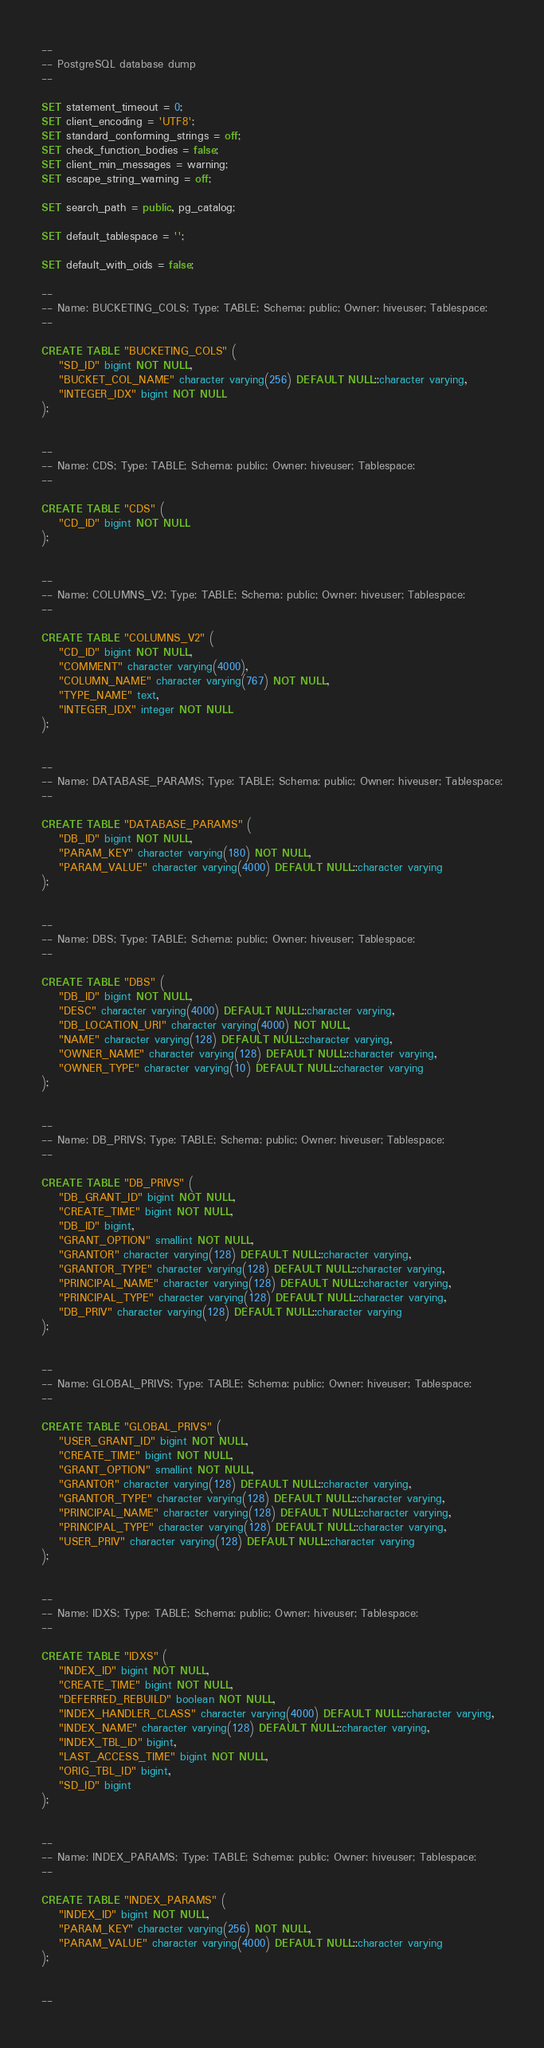Convert code to text. <code><loc_0><loc_0><loc_500><loc_500><_SQL_>--
-- PostgreSQL database dump
--

SET statement_timeout = 0;
SET client_encoding = 'UTF8';
SET standard_conforming_strings = off;
SET check_function_bodies = false;
SET client_min_messages = warning;
SET escape_string_warning = off;

SET search_path = public, pg_catalog;

SET default_tablespace = '';

SET default_with_oids = false;

--
-- Name: BUCKETING_COLS; Type: TABLE; Schema: public; Owner: hiveuser; Tablespace:
--

CREATE TABLE "BUCKETING_COLS" (
    "SD_ID" bigint NOT NULL,
    "BUCKET_COL_NAME" character varying(256) DEFAULT NULL::character varying,
    "INTEGER_IDX" bigint NOT NULL
);


--
-- Name: CDS; Type: TABLE; Schema: public; Owner: hiveuser; Tablespace:
--

CREATE TABLE "CDS" (
    "CD_ID" bigint NOT NULL
);


--
-- Name: COLUMNS_V2; Type: TABLE; Schema: public; Owner: hiveuser; Tablespace:
--

CREATE TABLE "COLUMNS_V2" (
    "CD_ID" bigint NOT NULL,
    "COMMENT" character varying(4000),
    "COLUMN_NAME" character varying(767) NOT NULL,
    "TYPE_NAME" text,
    "INTEGER_IDX" integer NOT NULL
);


--
-- Name: DATABASE_PARAMS; Type: TABLE; Schema: public; Owner: hiveuser; Tablespace:
--

CREATE TABLE "DATABASE_PARAMS" (
    "DB_ID" bigint NOT NULL,
    "PARAM_KEY" character varying(180) NOT NULL,
    "PARAM_VALUE" character varying(4000) DEFAULT NULL::character varying
);


--
-- Name: DBS; Type: TABLE; Schema: public; Owner: hiveuser; Tablespace:
--

CREATE TABLE "DBS" (
    "DB_ID" bigint NOT NULL,
    "DESC" character varying(4000) DEFAULT NULL::character varying,
    "DB_LOCATION_URI" character varying(4000) NOT NULL,
    "NAME" character varying(128) DEFAULT NULL::character varying,
    "OWNER_NAME" character varying(128) DEFAULT NULL::character varying,
    "OWNER_TYPE" character varying(10) DEFAULT NULL::character varying
);


--
-- Name: DB_PRIVS; Type: TABLE; Schema: public; Owner: hiveuser; Tablespace:
--

CREATE TABLE "DB_PRIVS" (
    "DB_GRANT_ID" bigint NOT NULL,
    "CREATE_TIME" bigint NOT NULL,
    "DB_ID" bigint,
    "GRANT_OPTION" smallint NOT NULL,
    "GRANTOR" character varying(128) DEFAULT NULL::character varying,
    "GRANTOR_TYPE" character varying(128) DEFAULT NULL::character varying,
    "PRINCIPAL_NAME" character varying(128) DEFAULT NULL::character varying,
    "PRINCIPAL_TYPE" character varying(128) DEFAULT NULL::character varying,
    "DB_PRIV" character varying(128) DEFAULT NULL::character varying
);


--
-- Name: GLOBAL_PRIVS; Type: TABLE; Schema: public; Owner: hiveuser; Tablespace:
--

CREATE TABLE "GLOBAL_PRIVS" (
    "USER_GRANT_ID" bigint NOT NULL,
    "CREATE_TIME" bigint NOT NULL,
    "GRANT_OPTION" smallint NOT NULL,
    "GRANTOR" character varying(128) DEFAULT NULL::character varying,
    "GRANTOR_TYPE" character varying(128) DEFAULT NULL::character varying,
    "PRINCIPAL_NAME" character varying(128) DEFAULT NULL::character varying,
    "PRINCIPAL_TYPE" character varying(128) DEFAULT NULL::character varying,
    "USER_PRIV" character varying(128) DEFAULT NULL::character varying
);


--
-- Name: IDXS; Type: TABLE; Schema: public; Owner: hiveuser; Tablespace:
--

CREATE TABLE "IDXS" (
    "INDEX_ID" bigint NOT NULL,
    "CREATE_TIME" bigint NOT NULL,
    "DEFERRED_REBUILD" boolean NOT NULL,
    "INDEX_HANDLER_CLASS" character varying(4000) DEFAULT NULL::character varying,
    "INDEX_NAME" character varying(128) DEFAULT NULL::character varying,
    "INDEX_TBL_ID" bigint,
    "LAST_ACCESS_TIME" bigint NOT NULL,
    "ORIG_TBL_ID" bigint,
    "SD_ID" bigint
);


--
-- Name: INDEX_PARAMS; Type: TABLE; Schema: public; Owner: hiveuser; Tablespace:
--

CREATE TABLE "INDEX_PARAMS" (
    "INDEX_ID" bigint NOT NULL,
    "PARAM_KEY" character varying(256) NOT NULL,
    "PARAM_VALUE" character varying(4000) DEFAULT NULL::character varying
);


--</code> 